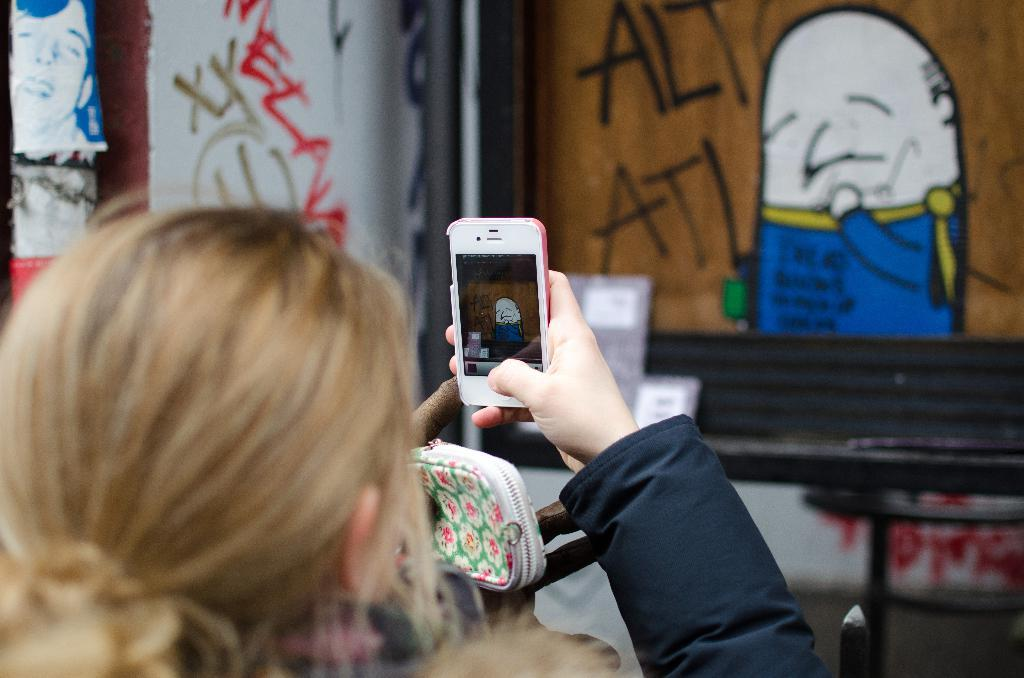Who is the main subject in the image? There is a woman in the image. What is the woman holding in the image? The woman is holding a mobile. What is the woman doing with the mobile? The woman is taking a picture of a cartoon on the wall. What object is visible behind the woman? There is a purse behind the woman. Where is the photo of a person located in the image? There is a photo of a person in the top left corner of the image. What type of knowledge can be gained from visiting the zoo in the image? There is no zoo present in the image, so no knowledge about a zoo can be gained from it. 